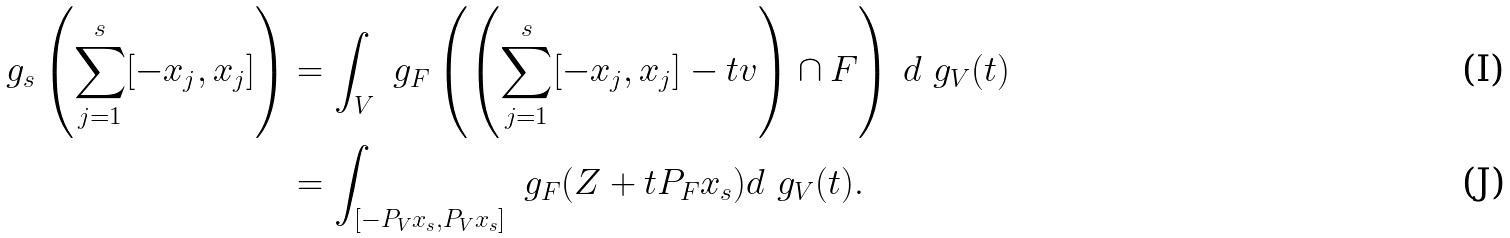Convert formula to latex. <formula><loc_0><loc_0><loc_500><loc_500>\ g _ { s } \left ( \sum _ { j = 1 } ^ { s } [ - x _ { j } , x _ { j } ] \right ) & = \int _ { V } \ g _ { F } \left ( \left ( \sum _ { j = 1 } ^ { s } [ - x _ { j } , x _ { j } ] - t v \right ) \cap F \right ) \, d \ g _ { V } ( t ) \\ & = \int _ { [ - P _ { V } x _ { s } , P _ { V } x _ { s } ] } \ g _ { F } ( Z + t P _ { F } x _ { s } ) d \ g _ { V } ( t ) .</formula> 